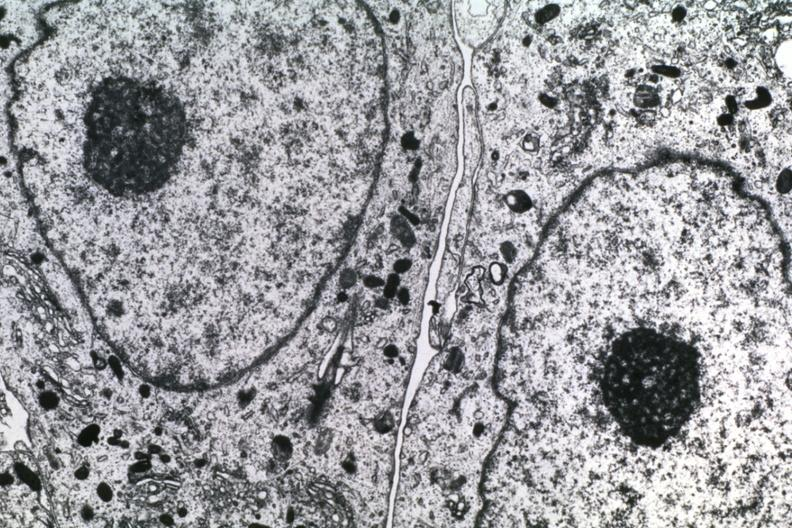what is present?
Answer the question using a single word or phrase. Subependymal giant cell astrocytoma 